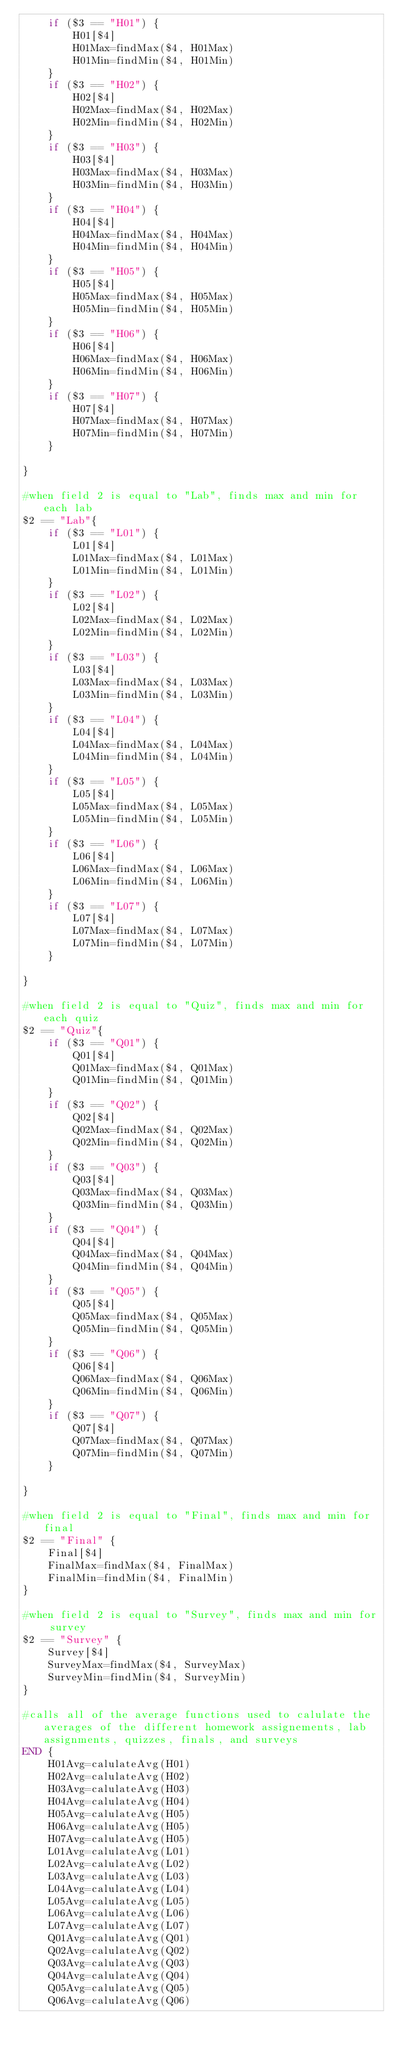Convert code to text. <code><loc_0><loc_0><loc_500><loc_500><_Awk_>    if ($3 == "H01") {
        H01[$4]
        H01Max=findMax($4, H01Max)
        H01Min=findMin($4, H01Min)
    }
    if ($3 == "H02") {
        H02[$4]
        H02Max=findMax($4, H02Max)
        H02Min=findMin($4, H02Min)
    }
    if ($3 == "H03") {
        H03[$4]
        H03Max=findMax($4, H03Max)
        H03Min=findMin($4, H03Min)
    }
    if ($3 == "H04") {
        H04[$4]
        H04Max=findMax($4, H04Max)
        H04Min=findMin($4, H04Min)
    }
    if ($3 == "H05") {
        H05[$4]
        H05Max=findMax($4, H05Max)
        H05Min=findMin($4, H05Min)
    }
    if ($3 == "H06") {
        H06[$4]
        H06Max=findMax($4, H06Max)
        H06Min=findMin($4, H06Min)
    }
    if ($3 == "H07") {
        H07[$4]
        H07Max=findMax($4, H07Max)
        H07Min=findMin($4, H07Min)
    }

}

#when field 2 is equal to "Lab", finds max and min for each lab
$2 == "Lab"{
    if ($3 == "L01") {
        L01[$4]
        L01Max=findMax($4, L01Max)
        L01Min=findMin($4, L01Min)
    }
    if ($3 == "L02") {
        L02[$4]
        L02Max=findMax($4, L02Max)
        L02Min=findMin($4, L02Min)
    }
    if ($3 == "L03") {
        L03[$4]
        L03Max=findMax($4, L03Max)
        L03Min=findMin($4, L03Min)
    }
    if ($3 == "L04") {
        L04[$4]
        L04Max=findMax($4, L04Max)
        L04Min=findMin($4, L04Min)
    }
    if ($3 == "L05") {
        L05[$4]
        L05Max=findMax($4, L05Max)
        L05Min=findMin($4, L05Min)
    }
    if ($3 == "L06") {
        L06[$4]
        L06Max=findMax($4, L06Max)
        L06Min=findMin($4, L06Min)
    }
    if ($3 == "L07") {
        L07[$4]
        L07Max=findMax($4, L07Max)
        L07Min=findMin($4, L07Min)
    }

}

#when field 2 is equal to "Quiz", finds max and min for each quiz
$2 == "Quiz"{
    if ($3 == "Q01") {
        Q01[$4]
        Q01Max=findMax($4, Q01Max)
        Q01Min=findMin($4, Q01Min)
    }
    if ($3 == "Q02") {
        Q02[$4]
        Q02Max=findMax($4, Q02Max)
        Q02Min=findMin($4, Q02Min)
    }
    if ($3 == "Q03") {
        Q03[$4]
        Q03Max=findMax($4, Q03Max)
        Q03Min=findMin($4, Q03Min)
    }
    if ($3 == "Q04") {
        Q04[$4]
        Q04Max=findMax($4, Q04Max)
        Q04Min=findMin($4, Q04Min)
    }
    if ($3 == "Q05") {
        Q05[$4]
        Q05Max=findMax($4, Q05Max)
        Q05Min=findMin($4, Q05Min)
    }
    if ($3 == "Q06") {
        Q06[$4]
        Q06Max=findMax($4, Q06Max)
        Q06Min=findMin($4, Q06Min)
    }
    if ($3 == "Q07") {
        Q07[$4]
        Q07Max=findMax($4, Q07Max)
        Q07Min=findMin($4, Q07Min)
    }

}

#when field 2 is equal to "Final", finds max and min for final
$2 == "Final" {
    Final[$4]
    FinalMax=findMax($4, FinalMax)
    FinalMin=findMin($4, FinalMin)
}

#when field 2 is equal to "Survey", finds max and min for survey
$2 == "Survey" {
    Survey[$4]
    SurveyMax=findMax($4, SurveyMax)
    SurveyMin=findMin($4, SurveyMin)
}

#calls all of the average functions used to calulate the averages of the different homework assignements, lab assignments, quizzes, finals, and surveys
END {
    H01Avg=calulateAvg(H01)
    H02Avg=calulateAvg(H02)
    H03Avg=calulateAvg(H03)
    H04Avg=calulateAvg(H04)
    H05Avg=calulateAvg(H05)
    H06Avg=calulateAvg(H05)
    H07Avg=calulateAvg(H05)
    L01Avg=calulateAvg(L01)
    L02Avg=calulateAvg(L02)
    L03Avg=calulateAvg(L03)
    L04Avg=calulateAvg(L04)
    L05Avg=calulateAvg(L05)
    L06Avg=calulateAvg(L06)
    L07Avg=calulateAvg(L07)
    Q01Avg=calulateAvg(Q01)
    Q02Avg=calulateAvg(Q02)
    Q03Avg=calulateAvg(Q03)
    Q04Avg=calulateAvg(Q04)
    Q05Avg=calulateAvg(Q05)
    Q06Avg=calulateAvg(Q06)</code> 